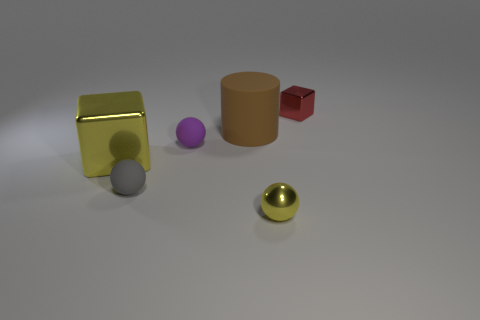What number of brown things are big metal cubes or matte blocks?
Your response must be concise. 0. Are there more tiny shiny balls that are on the left side of the gray matte ball than big cyan spheres?
Your answer should be compact. No. Is the size of the gray sphere the same as the purple ball?
Your answer should be compact. Yes. What is the color of the tiny sphere that is the same material as the tiny block?
Make the answer very short. Yellow. What shape is the thing that is the same color as the large block?
Your answer should be compact. Sphere. Is the number of large metallic things behind the purple ball the same as the number of gray matte objects right of the tiny gray rubber thing?
Provide a succinct answer. Yes. What is the shape of the yellow thing that is in front of the block that is in front of the large cylinder?
Ensure brevity in your answer.  Sphere. There is a tiny gray thing that is the same shape as the small yellow metal thing; what material is it?
Make the answer very short. Rubber. The shiny thing that is the same size as the red cube is what color?
Provide a succinct answer. Yellow. Is the number of red things in front of the large yellow metallic thing the same as the number of big green metallic things?
Your answer should be very brief. Yes. 